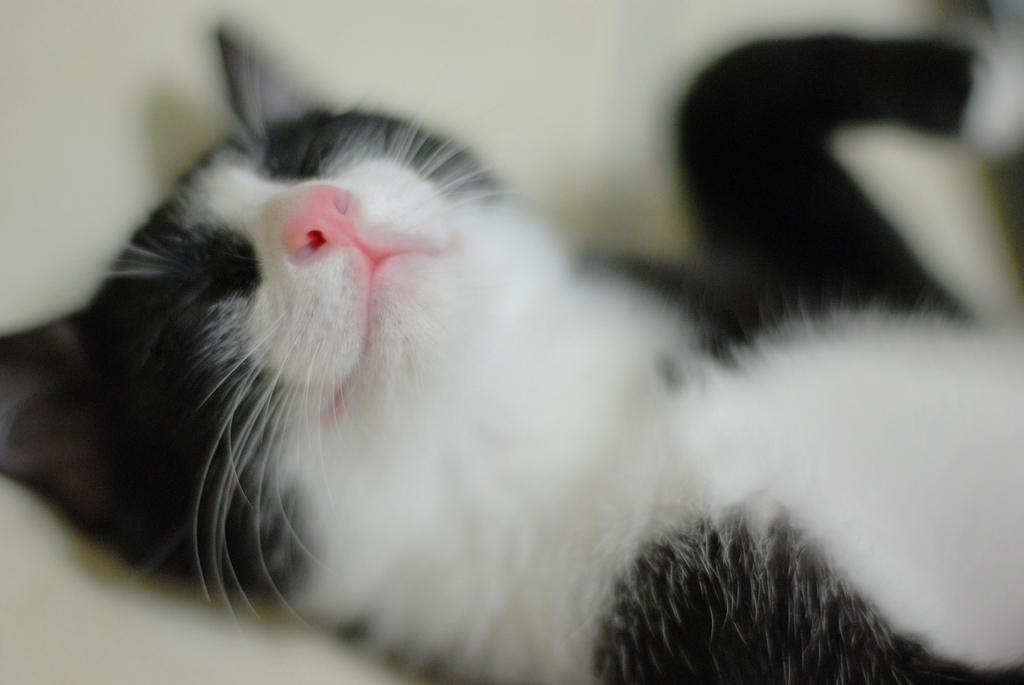What type of animal is in the image? There is a cat in the image. Where is the cat located in the image? The cat is on a surface. What is the cat's hope for the future in the image? There is no information about the cat's hopes or future in the image. 